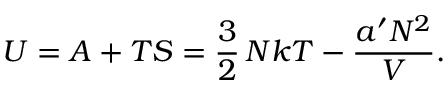Convert formula to latex. <formula><loc_0><loc_0><loc_500><loc_500>U = A + T S = { \frac { 3 } { 2 } } \, N k T - { \frac { a ^ { \prime } N ^ { 2 } } { V } } .</formula> 